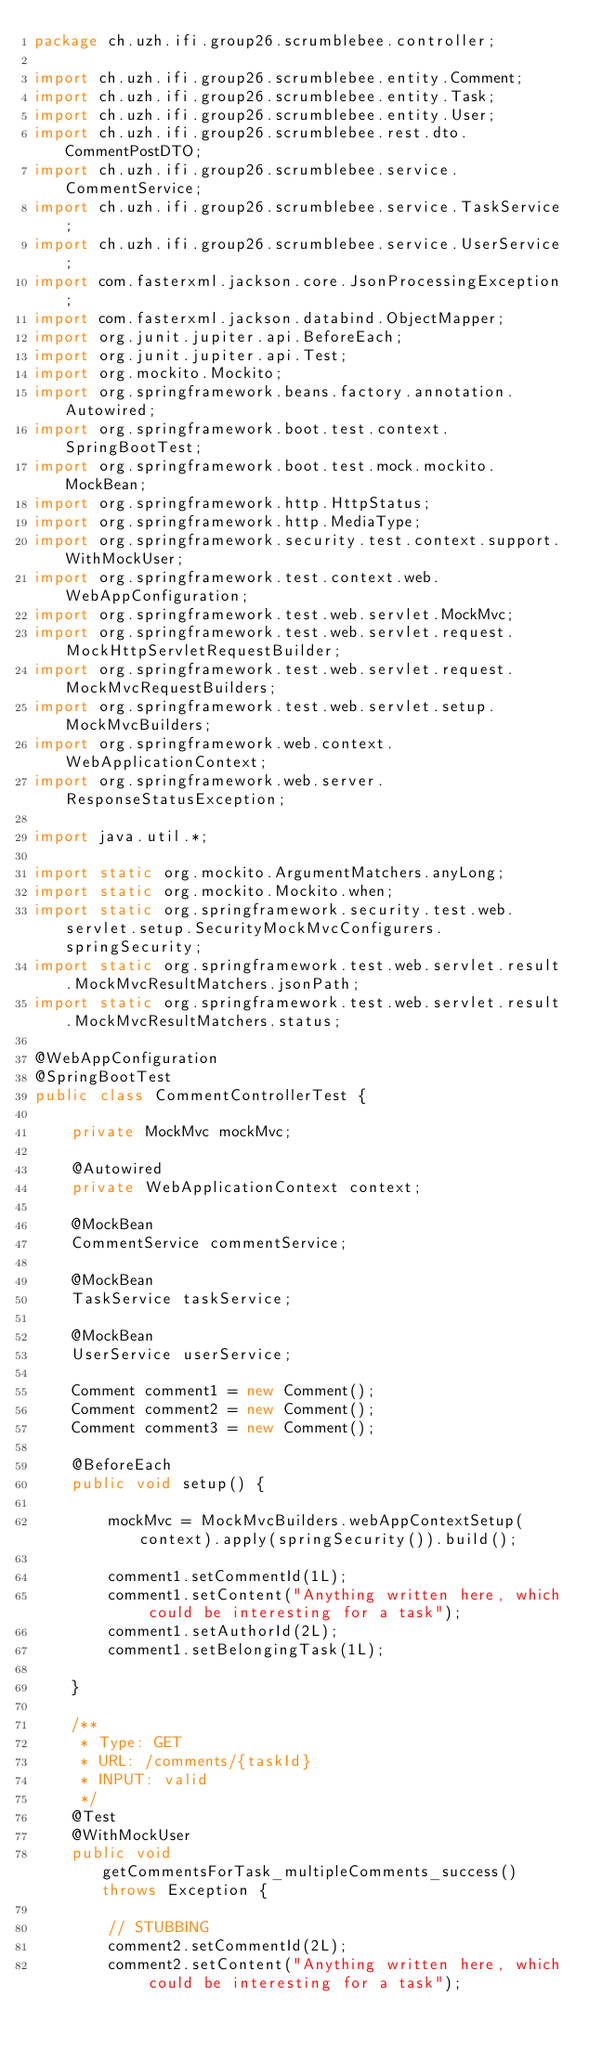Convert code to text. <code><loc_0><loc_0><loc_500><loc_500><_Java_>package ch.uzh.ifi.group26.scrumblebee.controller;

import ch.uzh.ifi.group26.scrumblebee.entity.Comment;
import ch.uzh.ifi.group26.scrumblebee.entity.Task;
import ch.uzh.ifi.group26.scrumblebee.entity.User;
import ch.uzh.ifi.group26.scrumblebee.rest.dto.CommentPostDTO;
import ch.uzh.ifi.group26.scrumblebee.service.CommentService;
import ch.uzh.ifi.group26.scrumblebee.service.TaskService;
import ch.uzh.ifi.group26.scrumblebee.service.UserService;
import com.fasterxml.jackson.core.JsonProcessingException;
import com.fasterxml.jackson.databind.ObjectMapper;
import org.junit.jupiter.api.BeforeEach;
import org.junit.jupiter.api.Test;
import org.mockito.Mockito;
import org.springframework.beans.factory.annotation.Autowired;
import org.springframework.boot.test.context.SpringBootTest;
import org.springframework.boot.test.mock.mockito.MockBean;
import org.springframework.http.HttpStatus;
import org.springframework.http.MediaType;
import org.springframework.security.test.context.support.WithMockUser;
import org.springframework.test.context.web.WebAppConfiguration;
import org.springframework.test.web.servlet.MockMvc;
import org.springframework.test.web.servlet.request.MockHttpServletRequestBuilder;
import org.springframework.test.web.servlet.request.MockMvcRequestBuilders;
import org.springframework.test.web.servlet.setup.MockMvcBuilders;
import org.springframework.web.context.WebApplicationContext;
import org.springframework.web.server.ResponseStatusException;

import java.util.*;

import static org.mockito.ArgumentMatchers.anyLong;
import static org.mockito.Mockito.when;
import static org.springframework.security.test.web.servlet.setup.SecurityMockMvcConfigurers.springSecurity;
import static org.springframework.test.web.servlet.result.MockMvcResultMatchers.jsonPath;
import static org.springframework.test.web.servlet.result.MockMvcResultMatchers.status;

@WebAppConfiguration
@SpringBootTest
public class CommentControllerTest {

    private MockMvc mockMvc;

    @Autowired
    private WebApplicationContext context;

    @MockBean
    CommentService commentService;

    @MockBean
    TaskService taskService;

    @MockBean
    UserService userService;

    Comment comment1 = new Comment();
    Comment comment2 = new Comment();
    Comment comment3 = new Comment();

    @BeforeEach
    public void setup() {

        mockMvc = MockMvcBuilders.webAppContextSetup(context).apply(springSecurity()).build();

        comment1.setCommentId(1L);
        comment1.setContent("Anything written here, which could be interesting for a task");
        comment1.setAuthorId(2L);
        comment1.setBelongingTask(1L);

    }

    /**
     * Type: GET
     * URL: /comments/{taskId}
     * INPUT: valid
     */
    @Test
    @WithMockUser
    public void getCommentsForTask_multipleComments_success() throws Exception {

        // STUBBING
        comment2.setCommentId(2L);
        comment2.setContent("Anything written here, which could be interesting for a task");</code> 